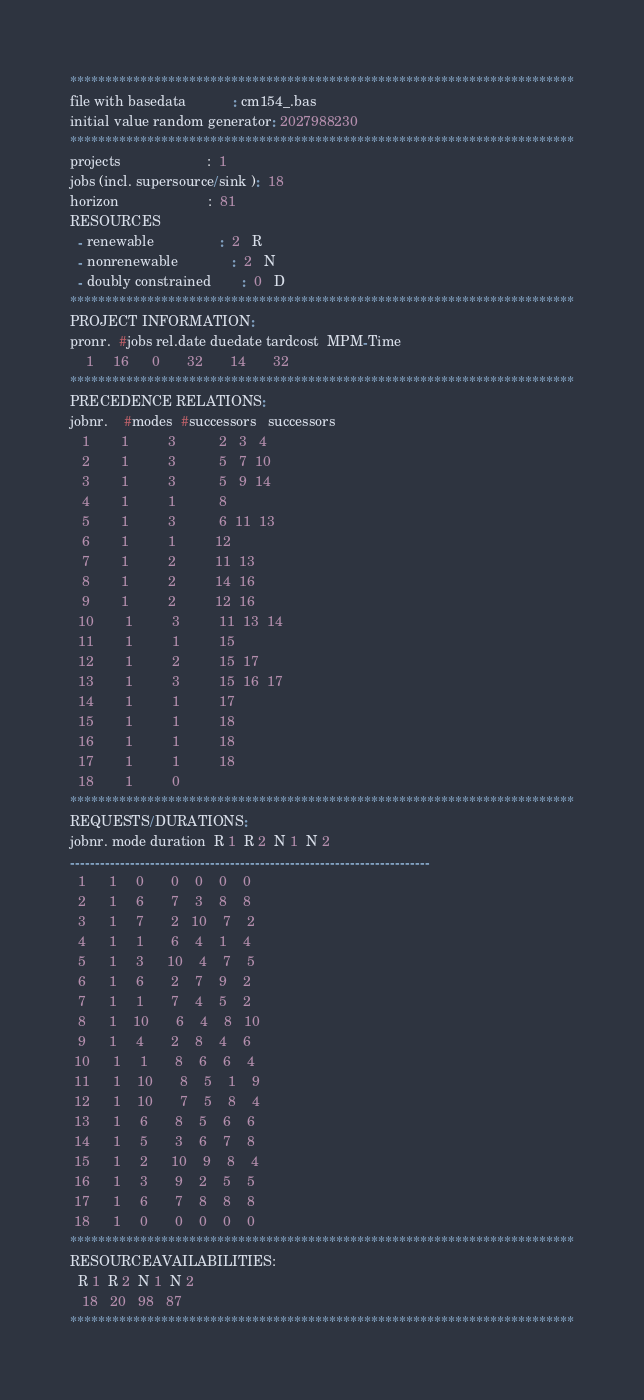Convert code to text. <code><loc_0><loc_0><loc_500><loc_500><_ObjectiveC_>************************************************************************
file with basedata            : cm154_.bas
initial value random generator: 2027988230
************************************************************************
projects                      :  1
jobs (incl. supersource/sink ):  18
horizon                       :  81
RESOURCES
  - renewable                 :  2   R
  - nonrenewable              :  2   N
  - doubly constrained        :  0   D
************************************************************************
PROJECT INFORMATION:
pronr.  #jobs rel.date duedate tardcost  MPM-Time
    1     16      0       32       14       32
************************************************************************
PRECEDENCE RELATIONS:
jobnr.    #modes  #successors   successors
   1        1          3           2   3   4
   2        1          3           5   7  10
   3        1          3           5   9  14
   4        1          1           8
   5        1          3           6  11  13
   6        1          1          12
   7        1          2          11  13
   8        1          2          14  16
   9        1          2          12  16
  10        1          3          11  13  14
  11        1          1          15
  12        1          2          15  17
  13        1          3          15  16  17
  14        1          1          17
  15        1          1          18
  16        1          1          18
  17        1          1          18
  18        1          0        
************************************************************************
REQUESTS/DURATIONS:
jobnr. mode duration  R 1  R 2  N 1  N 2
------------------------------------------------------------------------
  1      1     0       0    0    0    0
  2      1     6       7    3    8    8
  3      1     7       2   10    7    2
  4      1     1       6    4    1    4
  5      1     3      10    4    7    5
  6      1     6       2    7    9    2
  7      1     1       7    4    5    2
  8      1    10       6    4    8   10
  9      1     4       2    8    4    6
 10      1     1       8    6    6    4
 11      1    10       8    5    1    9
 12      1    10       7    5    8    4
 13      1     6       8    5    6    6
 14      1     5       3    6    7    8
 15      1     2      10    9    8    4
 16      1     3       9    2    5    5
 17      1     6       7    8    8    8
 18      1     0       0    0    0    0
************************************************************************
RESOURCEAVAILABILITIES:
  R 1  R 2  N 1  N 2
   18   20   98   87
************************************************************************
</code> 